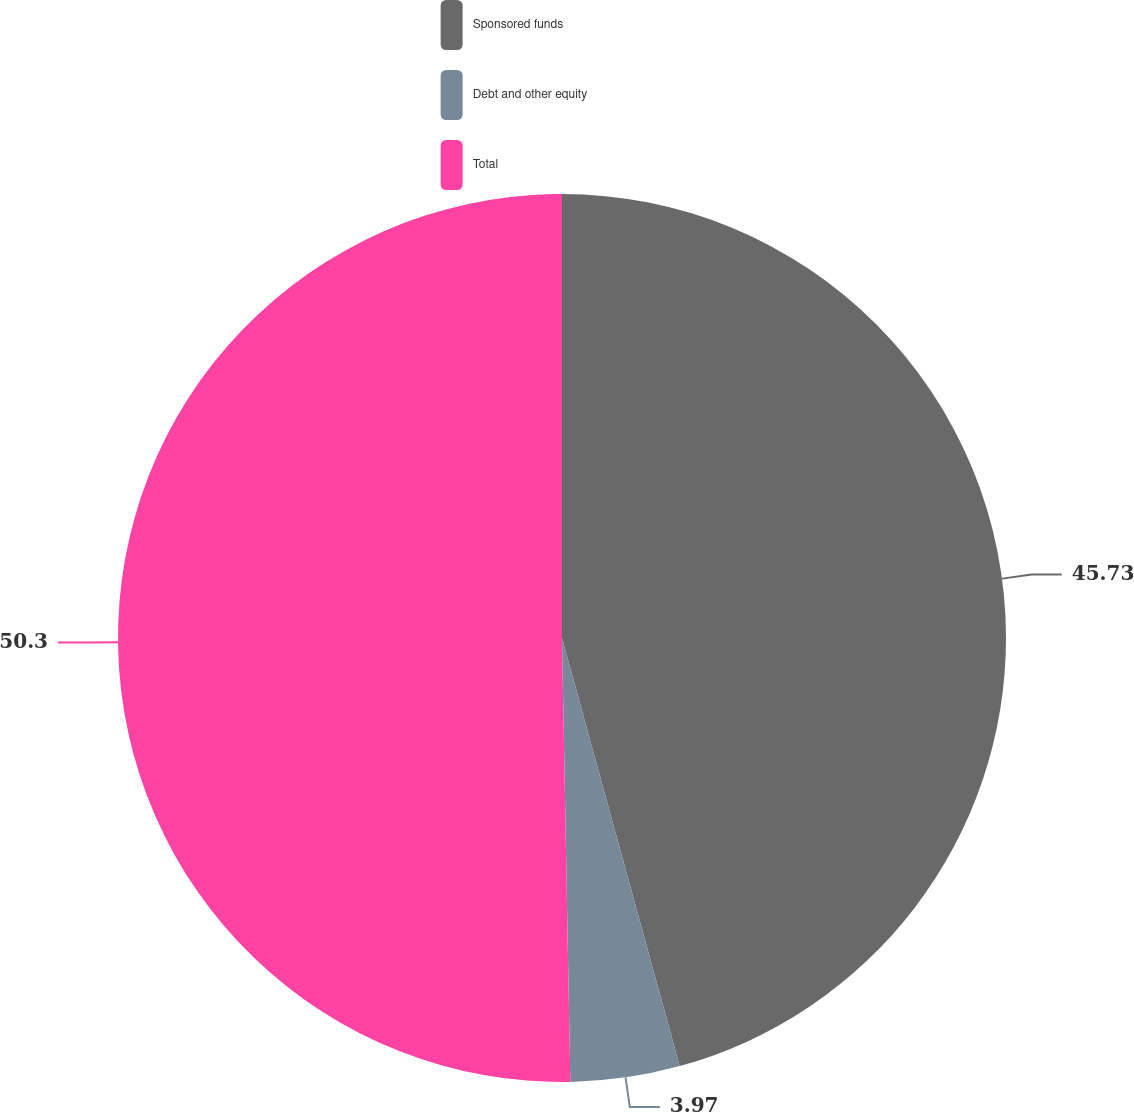<chart> <loc_0><loc_0><loc_500><loc_500><pie_chart><fcel>Sponsored funds<fcel>Debt and other equity<fcel>Total<nl><fcel>45.73%<fcel>3.97%<fcel>50.3%<nl></chart> 